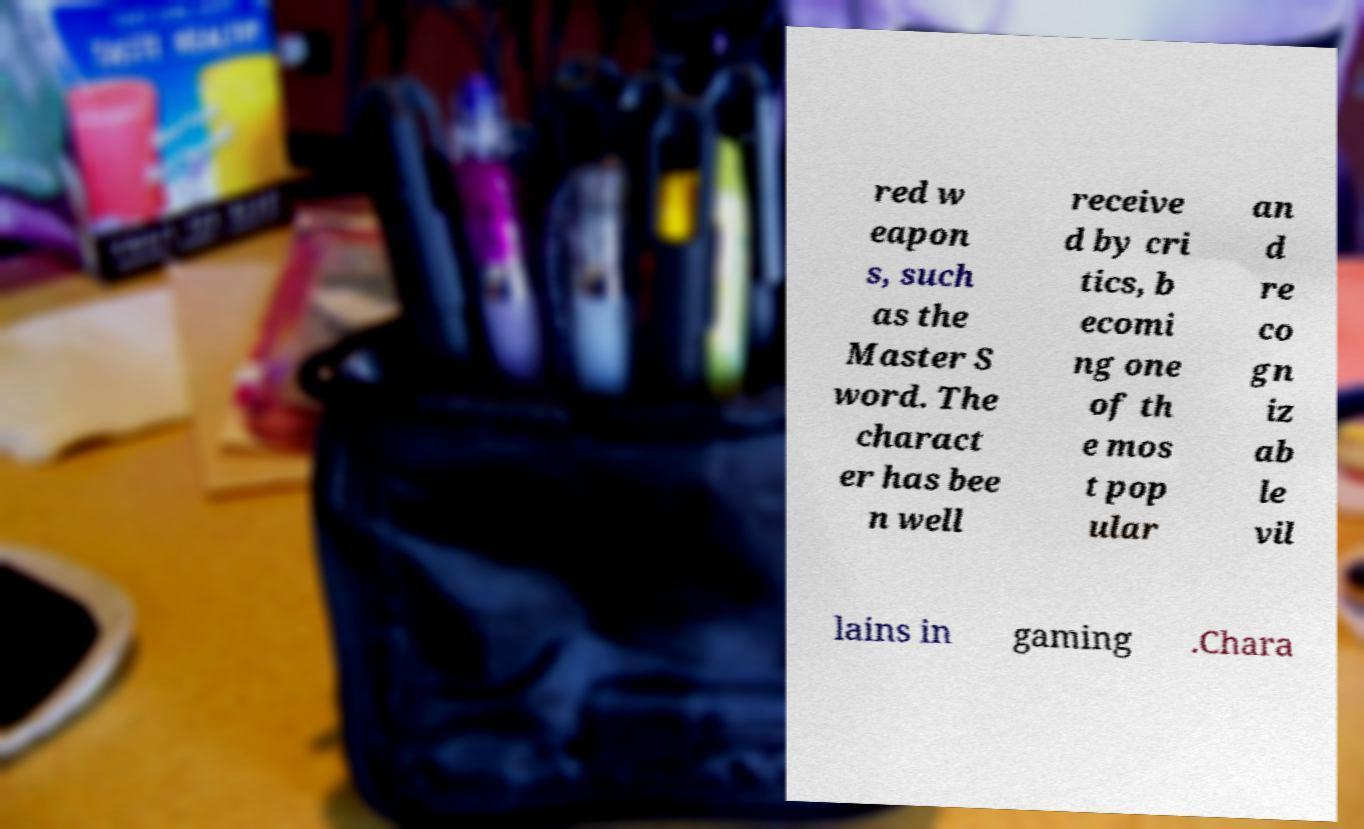What messages or text are displayed in this image? I need them in a readable, typed format. red w eapon s, such as the Master S word. The charact er has bee n well receive d by cri tics, b ecomi ng one of th e mos t pop ular an d re co gn iz ab le vil lains in gaming .Chara 